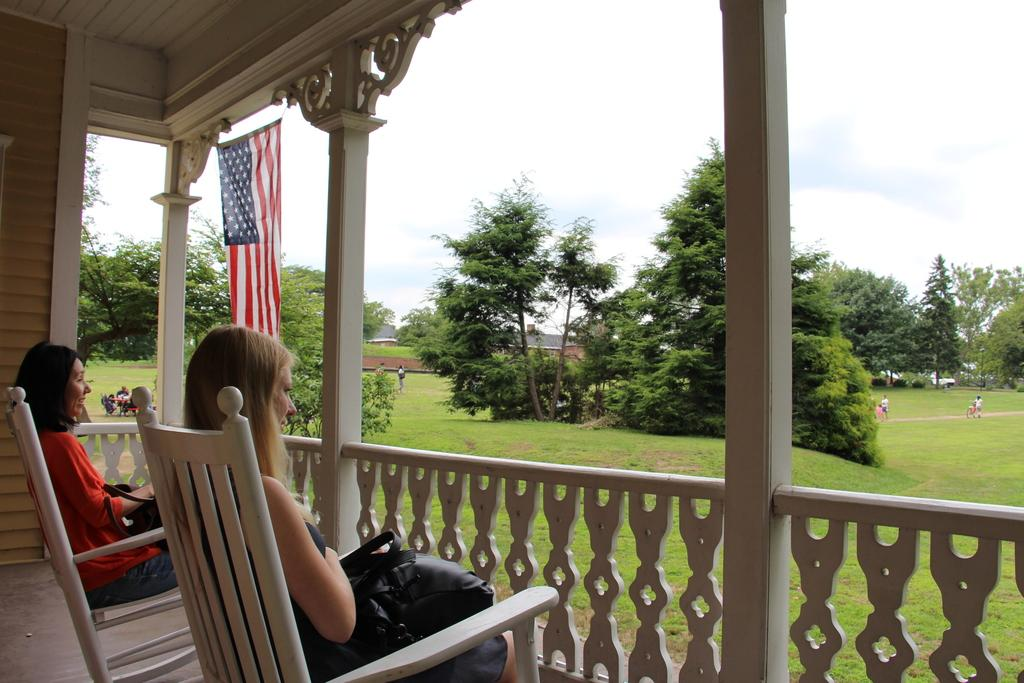How many people are sitting in the image? There are two persons sitting on chairs in the image. What type of surface are the chairs placed on? The chairs are placed on grass, as indicated by the presence of grass in the image. What other natural elements can be seen in the image? There are trees in the image. What is the background of the image? The sky is visible in the background of the image. What additional object is present in the image? There is a flag in the image. What type of appliance can be seen in the image? There is no appliance present in the image. How many birds are flying in the image? There are no birds visible in the image. 